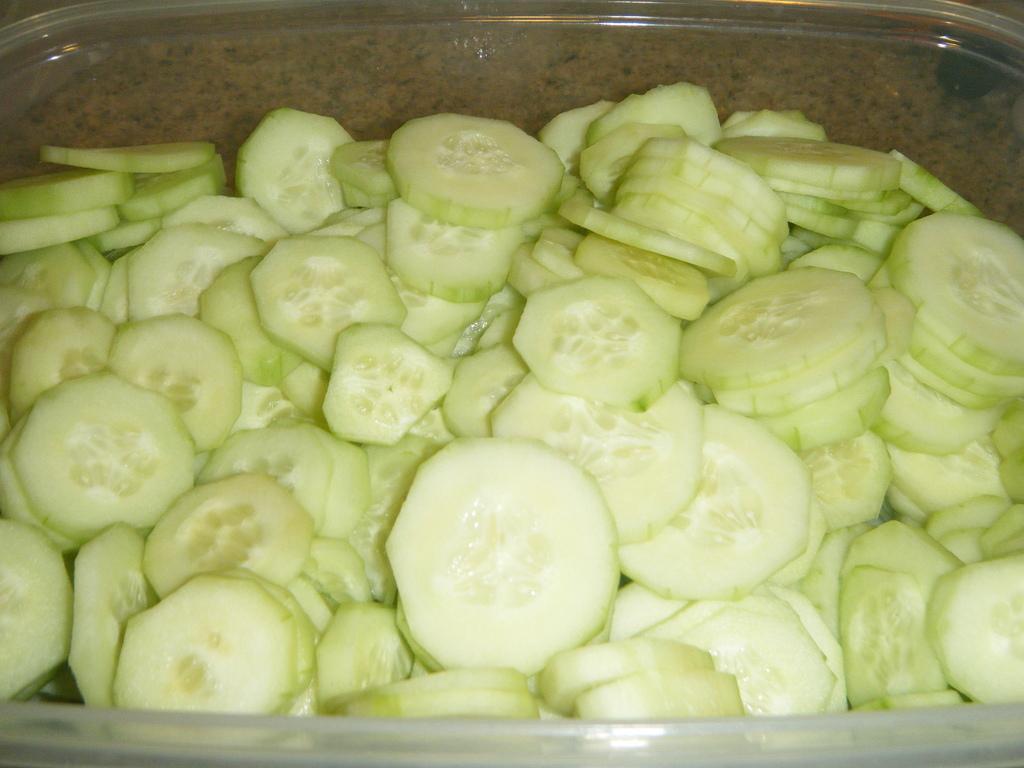In one or two sentences, can you explain what this image depicts? In this image, we can see some cucumber pieces in the container. 